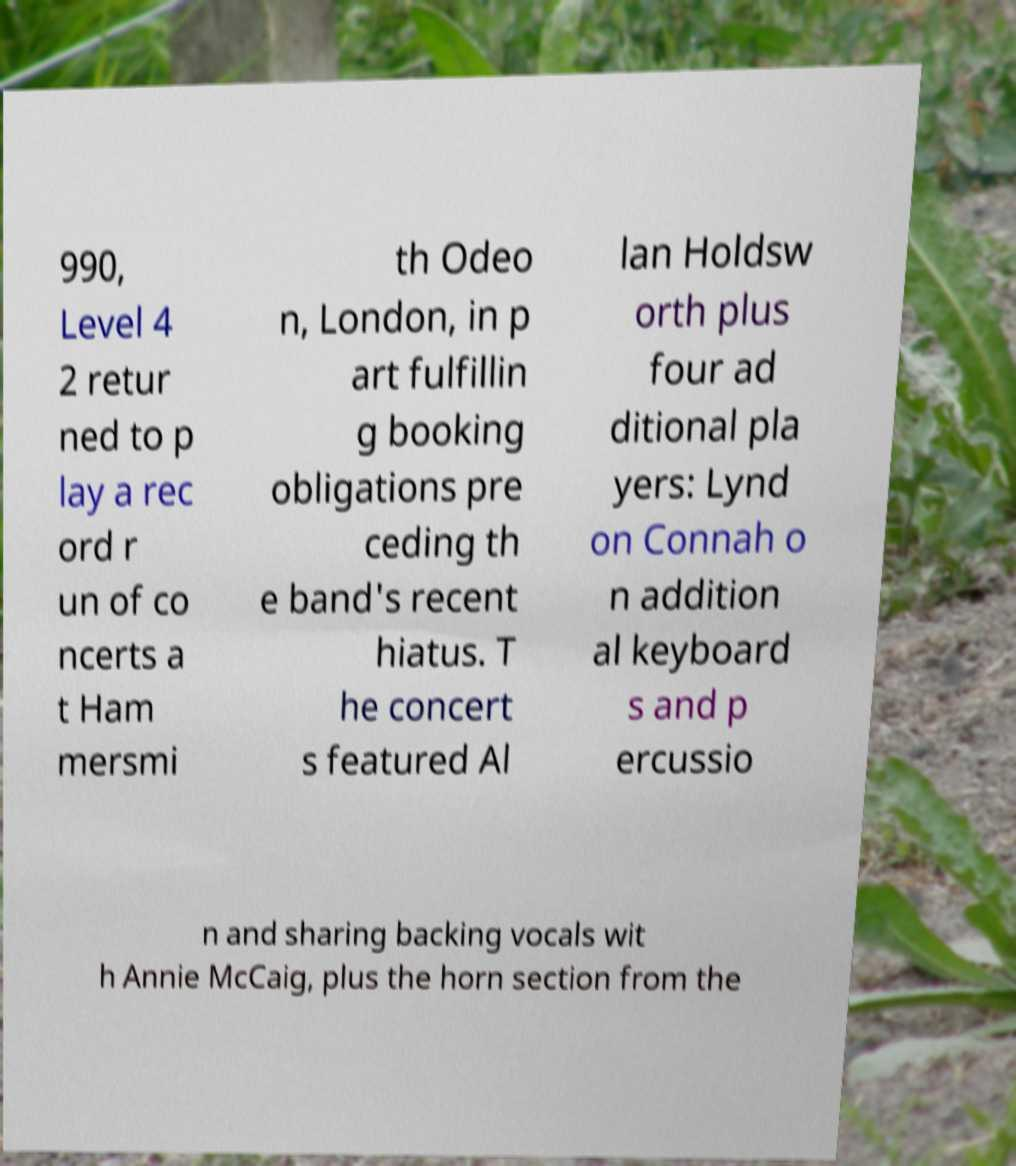What messages or text are displayed in this image? I need them in a readable, typed format. 990, Level 4 2 retur ned to p lay a rec ord r un of co ncerts a t Ham mersmi th Odeo n, London, in p art fulfillin g booking obligations pre ceding th e band's recent hiatus. T he concert s featured Al lan Holdsw orth plus four ad ditional pla yers: Lynd on Connah o n addition al keyboard s and p ercussio n and sharing backing vocals wit h Annie McCaig, plus the horn section from the 